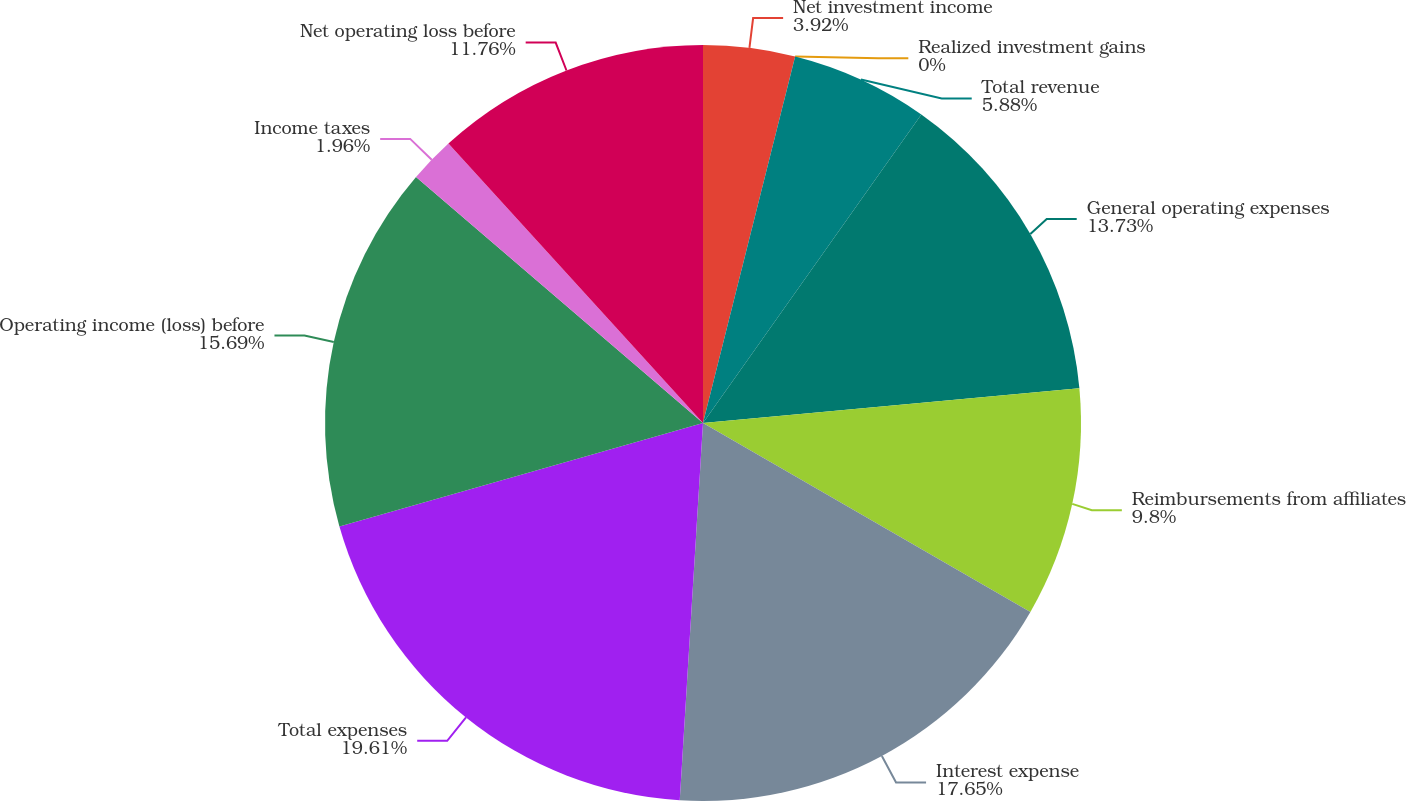<chart> <loc_0><loc_0><loc_500><loc_500><pie_chart><fcel>Net investment income<fcel>Realized investment gains<fcel>Total revenue<fcel>General operating expenses<fcel>Reimbursements from affiliates<fcel>Interest expense<fcel>Total expenses<fcel>Operating income (loss) before<fcel>Income taxes<fcel>Net operating loss before<nl><fcel>3.92%<fcel>0.0%<fcel>5.88%<fcel>13.73%<fcel>9.8%<fcel>17.65%<fcel>19.61%<fcel>15.69%<fcel>1.96%<fcel>11.76%<nl></chart> 